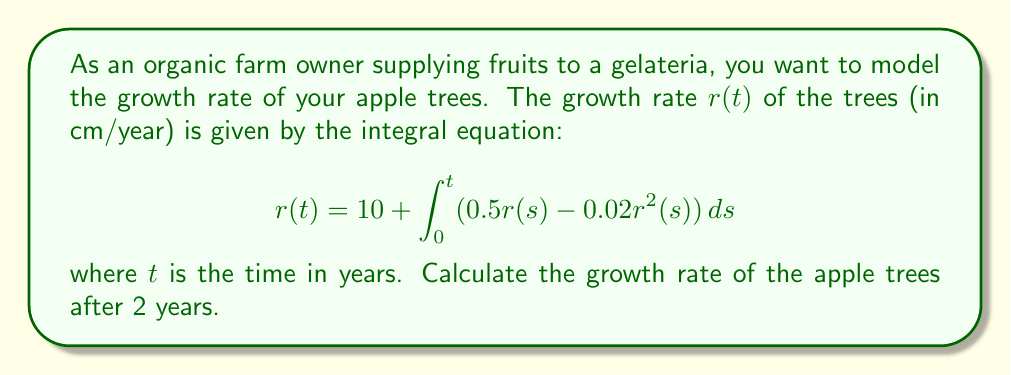What is the answer to this math problem? To solve this integral equation, we'll use the following steps:

1) First, we need to differentiate both sides of the equation with respect to $t$:

   $$\frac{d}{dt}r(t) = \frac{d}{dt}\left(10 + \int_0^t (0.5r(s) - 0.02r^2(s)) ds\right)$$

2) Using the Fundamental Theorem of Calculus, we get:

   $$\frac{dr}{dt} = 0.5r(t) - 0.02r^2(t)$$

3) This is now a differential equation. We can solve it using separation of variables:

   $$\frac{dr}{0.5r - 0.02r^2} = dt$$

4) Integrating both sides:

   $$\int \frac{dr}{0.5r - 0.02r^2} = \int dt$$

5) The left side can be integrated using partial fractions:

   $$-\frac{1}{0.5} \ln|0.5 - 0.02r| = t + C$$

6) Solving for $r$:

   $$r(t) = 25 - \frac{25}{1 + Ce^{0.5t}}$$

7) Using the initial condition $r(0) = 10$ (from the original equation), we can find $C$:

   $$10 = 25 - \frac{25}{1 + C} \implies C = \frac{5}{3}$$

8) Therefore, the solution is:

   $$r(t) = 25 - \frac{25}{1 + \frac{5}{3}e^{0.5t}}$$

9) To find $r(2)$, we substitute $t = 2$:

   $$r(2) = 25 - \frac{25}{1 + \frac{5}{3}e^{1}} \approx 18.65$$
Answer: $18.65$ cm/year 